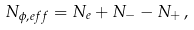Convert formula to latex. <formula><loc_0><loc_0><loc_500><loc_500>N _ { \phi , e f f } = N _ { e } + N _ { - } - N _ { + } \, ,</formula> 